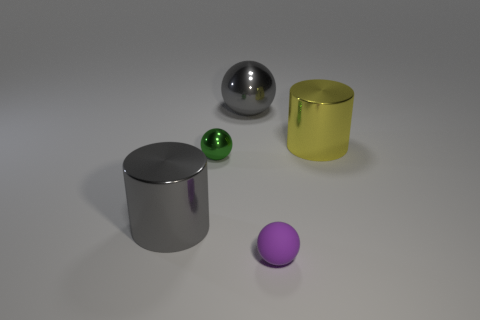What is the size of the object that is the same color as the big ball?
Ensure brevity in your answer.  Large. Are there more large gray things that are in front of the tiny matte thing than green spheres?
Your answer should be very brief. No. There is a tiny green shiny object; is it the same shape as the tiny thing that is in front of the gray metallic cylinder?
Your response must be concise. Yes. What number of gray spheres have the same size as the green metallic thing?
Offer a very short reply. 0. There is a large gray shiny object that is right of the big gray thing that is in front of the gray metal sphere; how many large gray metal objects are left of it?
Ensure brevity in your answer.  1. Are there an equal number of gray shiny objects that are left of the purple rubber sphere and gray cylinders behind the small green metal sphere?
Make the answer very short. No. What number of brown things are the same shape as the tiny purple rubber thing?
Make the answer very short. 0. Are there any big gray things that have the same material as the small green sphere?
Provide a succinct answer. Yes. There is a big object that is the same color as the large ball; what is its shape?
Your response must be concise. Cylinder. How many large blue matte things are there?
Your answer should be very brief. 0. 